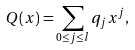Convert formula to latex. <formula><loc_0><loc_0><loc_500><loc_500>Q ( x ) = \sum _ { 0 \leq j \leq l } q _ { j } x ^ { j } ,</formula> 